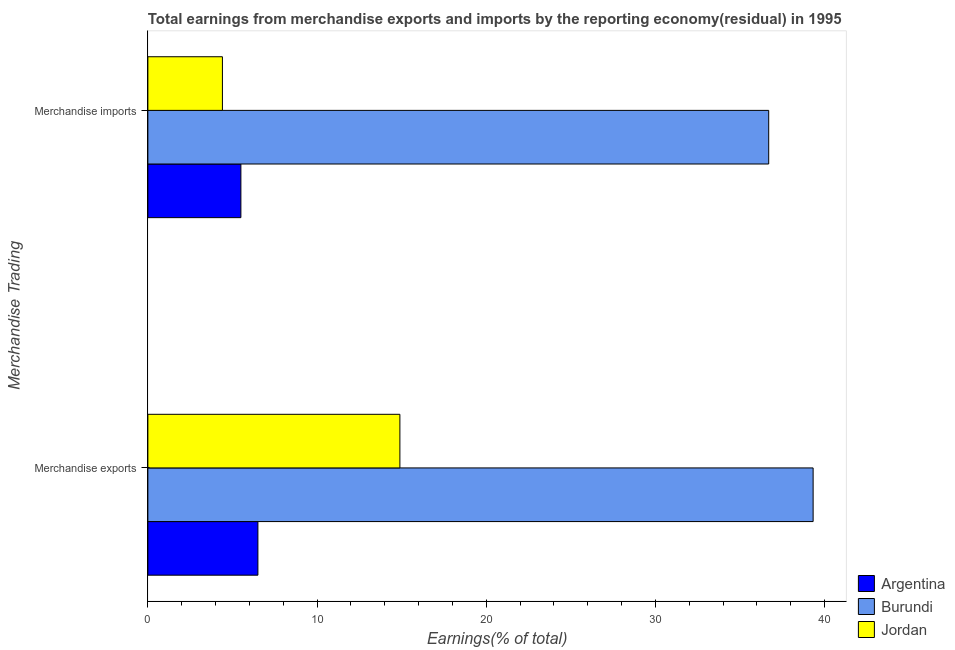How many bars are there on the 2nd tick from the top?
Offer a very short reply. 3. How many bars are there on the 2nd tick from the bottom?
Offer a very short reply. 3. What is the label of the 1st group of bars from the top?
Your response must be concise. Merchandise imports. What is the earnings from merchandise exports in Jordan?
Your answer should be compact. 14.9. Across all countries, what is the maximum earnings from merchandise exports?
Ensure brevity in your answer.  39.33. Across all countries, what is the minimum earnings from merchandise imports?
Give a very brief answer. 4.41. In which country was the earnings from merchandise imports maximum?
Ensure brevity in your answer.  Burundi. In which country was the earnings from merchandise imports minimum?
Provide a succinct answer. Jordan. What is the total earnings from merchandise imports in the graph?
Provide a short and direct response. 46.61. What is the difference between the earnings from merchandise imports in Burundi and that in Argentina?
Provide a short and direct response. 31.2. What is the difference between the earnings from merchandise imports in Burundi and the earnings from merchandise exports in Jordan?
Provide a succinct answer. 21.8. What is the average earnings from merchandise exports per country?
Your answer should be very brief. 20.24. What is the difference between the earnings from merchandise exports and earnings from merchandise imports in Jordan?
Provide a short and direct response. 10.49. In how many countries, is the earnings from merchandise imports greater than 8 %?
Your answer should be compact. 1. What is the ratio of the earnings from merchandise imports in Jordan to that in Burundi?
Provide a short and direct response. 0.12. What does the 2nd bar from the top in Merchandise imports represents?
Ensure brevity in your answer.  Burundi. How many bars are there?
Give a very brief answer. 6. Are all the bars in the graph horizontal?
Offer a terse response. Yes. How many countries are there in the graph?
Offer a very short reply. 3. Does the graph contain grids?
Make the answer very short. No. Where does the legend appear in the graph?
Offer a very short reply. Bottom right. How are the legend labels stacked?
Your response must be concise. Vertical. What is the title of the graph?
Offer a very short reply. Total earnings from merchandise exports and imports by the reporting economy(residual) in 1995. Does "Least developed countries" appear as one of the legend labels in the graph?
Offer a terse response. No. What is the label or title of the X-axis?
Ensure brevity in your answer.  Earnings(% of total). What is the label or title of the Y-axis?
Make the answer very short. Merchandise Trading. What is the Earnings(% of total) in Argentina in Merchandise exports?
Provide a succinct answer. 6.51. What is the Earnings(% of total) in Burundi in Merchandise exports?
Provide a short and direct response. 39.33. What is the Earnings(% of total) of Jordan in Merchandise exports?
Ensure brevity in your answer.  14.9. What is the Earnings(% of total) of Argentina in Merchandise imports?
Provide a short and direct response. 5.5. What is the Earnings(% of total) in Burundi in Merchandise imports?
Make the answer very short. 36.7. What is the Earnings(% of total) in Jordan in Merchandise imports?
Offer a very short reply. 4.41. Across all Merchandise Trading, what is the maximum Earnings(% of total) of Argentina?
Offer a terse response. 6.51. Across all Merchandise Trading, what is the maximum Earnings(% of total) of Burundi?
Keep it short and to the point. 39.33. Across all Merchandise Trading, what is the maximum Earnings(% of total) in Jordan?
Offer a very short reply. 14.9. Across all Merchandise Trading, what is the minimum Earnings(% of total) of Argentina?
Keep it short and to the point. 5.5. Across all Merchandise Trading, what is the minimum Earnings(% of total) in Burundi?
Keep it short and to the point. 36.7. Across all Merchandise Trading, what is the minimum Earnings(% of total) in Jordan?
Your answer should be very brief. 4.41. What is the total Earnings(% of total) of Argentina in the graph?
Ensure brevity in your answer.  12. What is the total Earnings(% of total) in Burundi in the graph?
Make the answer very short. 76.03. What is the total Earnings(% of total) in Jordan in the graph?
Make the answer very short. 19.31. What is the difference between the Earnings(% of total) in Argentina in Merchandise exports and that in Merchandise imports?
Keep it short and to the point. 1.01. What is the difference between the Earnings(% of total) of Burundi in Merchandise exports and that in Merchandise imports?
Give a very brief answer. 2.63. What is the difference between the Earnings(% of total) in Jordan in Merchandise exports and that in Merchandise imports?
Give a very brief answer. 10.49. What is the difference between the Earnings(% of total) in Argentina in Merchandise exports and the Earnings(% of total) in Burundi in Merchandise imports?
Make the answer very short. -30.2. What is the difference between the Earnings(% of total) in Argentina in Merchandise exports and the Earnings(% of total) in Jordan in Merchandise imports?
Offer a very short reply. 2.1. What is the difference between the Earnings(% of total) of Burundi in Merchandise exports and the Earnings(% of total) of Jordan in Merchandise imports?
Ensure brevity in your answer.  34.92. What is the average Earnings(% of total) in Argentina per Merchandise Trading?
Your answer should be compact. 6. What is the average Earnings(% of total) in Burundi per Merchandise Trading?
Your response must be concise. 38.02. What is the average Earnings(% of total) of Jordan per Merchandise Trading?
Your answer should be compact. 9.65. What is the difference between the Earnings(% of total) in Argentina and Earnings(% of total) in Burundi in Merchandise exports?
Your answer should be very brief. -32.82. What is the difference between the Earnings(% of total) in Argentina and Earnings(% of total) in Jordan in Merchandise exports?
Your answer should be very brief. -8.39. What is the difference between the Earnings(% of total) in Burundi and Earnings(% of total) in Jordan in Merchandise exports?
Keep it short and to the point. 24.43. What is the difference between the Earnings(% of total) of Argentina and Earnings(% of total) of Burundi in Merchandise imports?
Keep it short and to the point. -31.2. What is the difference between the Earnings(% of total) of Argentina and Earnings(% of total) of Jordan in Merchandise imports?
Your answer should be very brief. 1.09. What is the difference between the Earnings(% of total) in Burundi and Earnings(% of total) in Jordan in Merchandise imports?
Offer a very short reply. 32.29. What is the ratio of the Earnings(% of total) in Argentina in Merchandise exports to that in Merchandise imports?
Provide a succinct answer. 1.18. What is the ratio of the Earnings(% of total) of Burundi in Merchandise exports to that in Merchandise imports?
Make the answer very short. 1.07. What is the ratio of the Earnings(% of total) in Jordan in Merchandise exports to that in Merchandise imports?
Ensure brevity in your answer.  3.38. What is the difference between the highest and the second highest Earnings(% of total) of Burundi?
Provide a succinct answer. 2.63. What is the difference between the highest and the second highest Earnings(% of total) in Jordan?
Give a very brief answer. 10.49. What is the difference between the highest and the lowest Earnings(% of total) of Argentina?
Give a very brief answer. 1.01. What is the difference between the highest and the lowest Earnings(% of total) of Burundi?
Offer a terse response. 2.63. What is the difference between the highest and the lowest Earnings(% of total) in Jordan?
Offer a terse response. 10.49. 